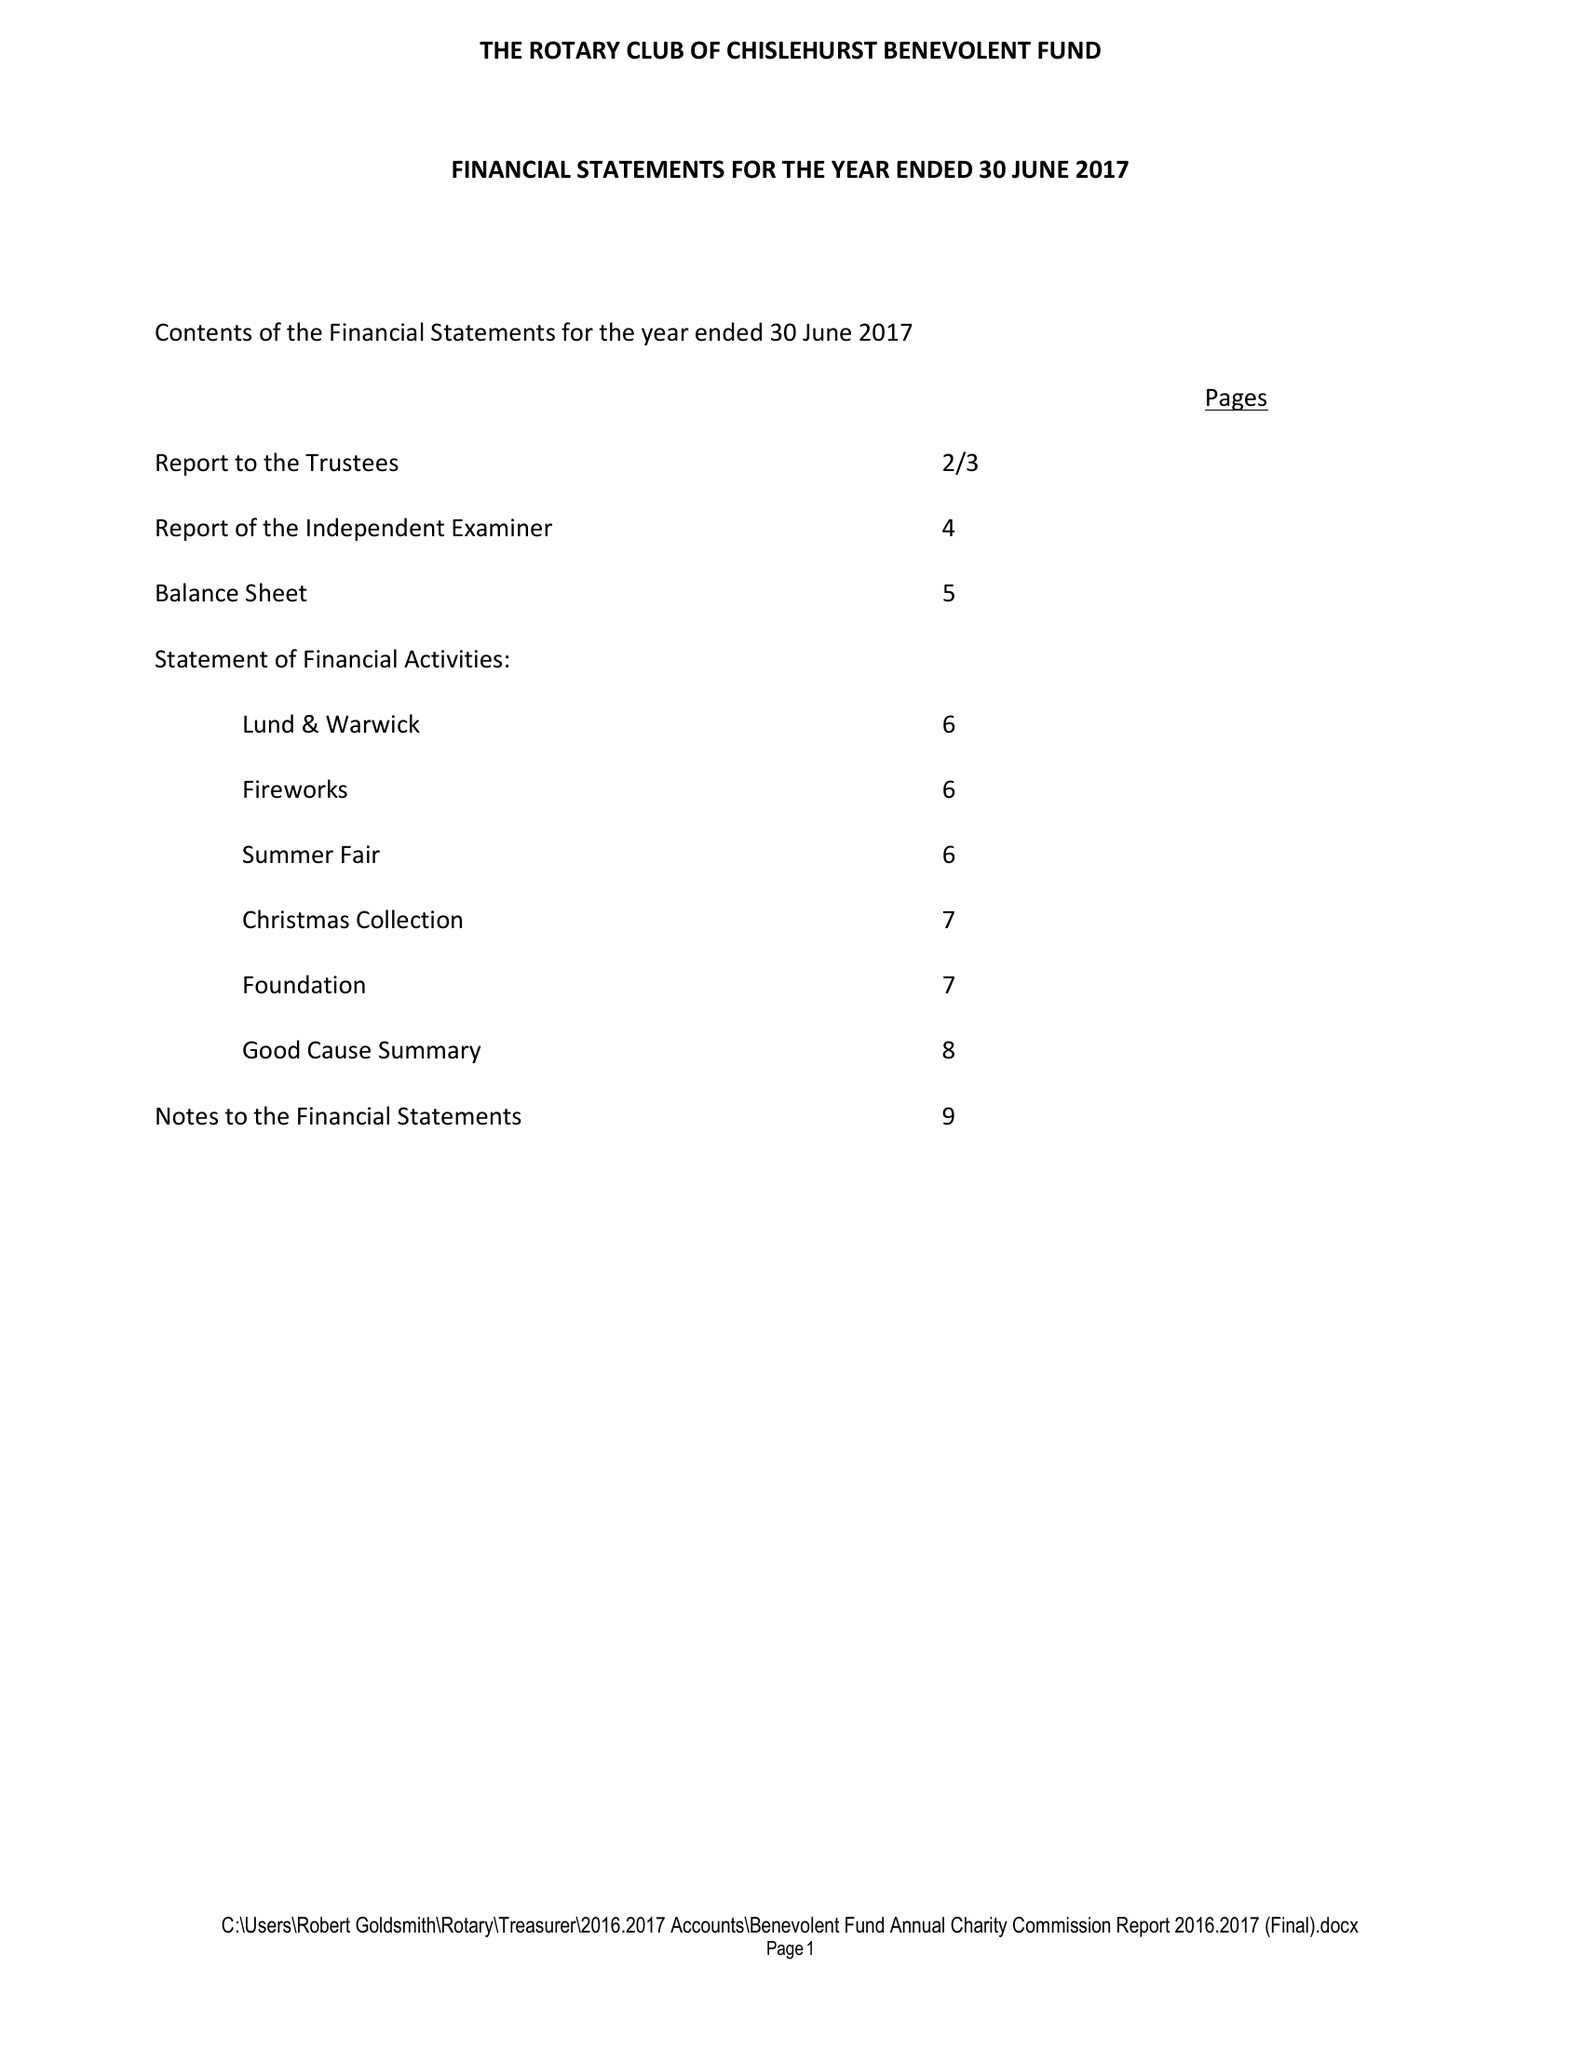What is the value for the report_date?
Answer the question using a single word or phrase. 2017-06-30 